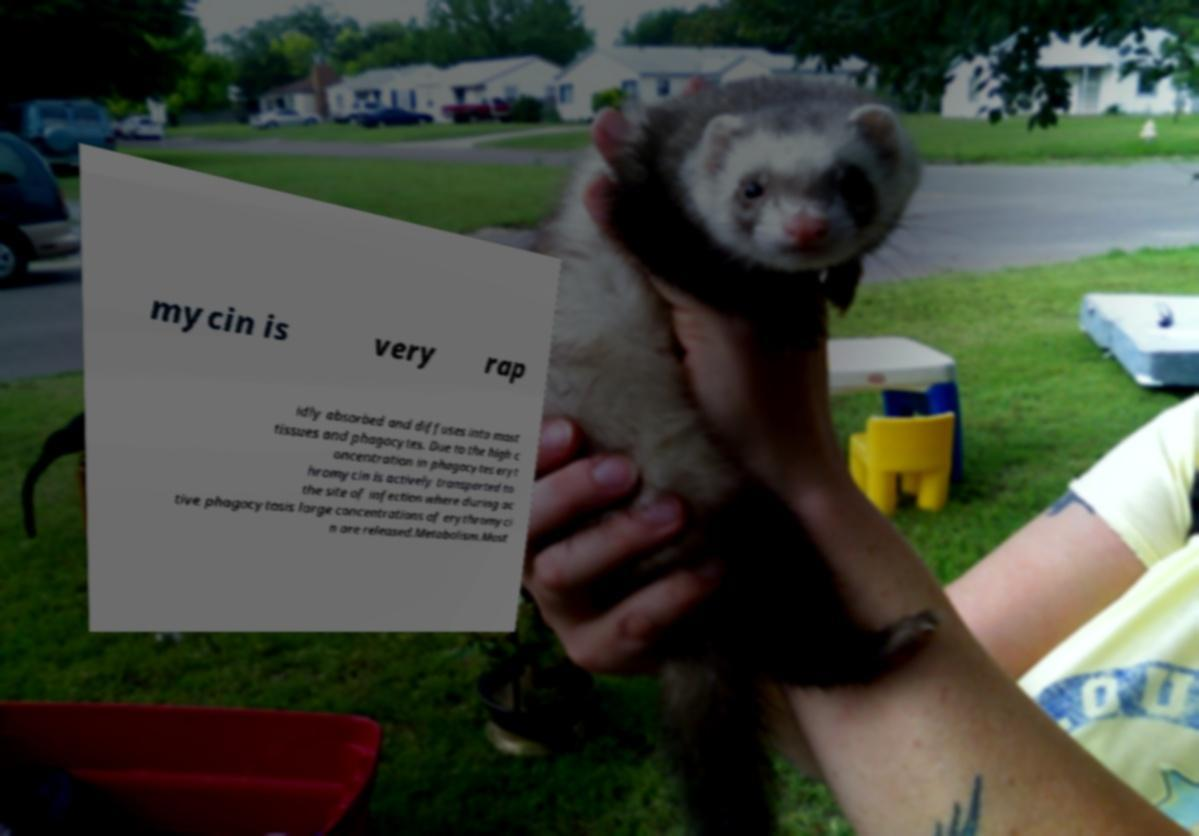I need the written content from this picture converted into text. Can you do that? mycin is very rap idly absorbed and diffuses into most tissues and phagocytes. Due to the high c oncentration in phagocytes eryt hromycin is actively transported to the site of infection where during ac tive phagocytosis large concentrations of erythromyci n are released.Metabolism.Most 